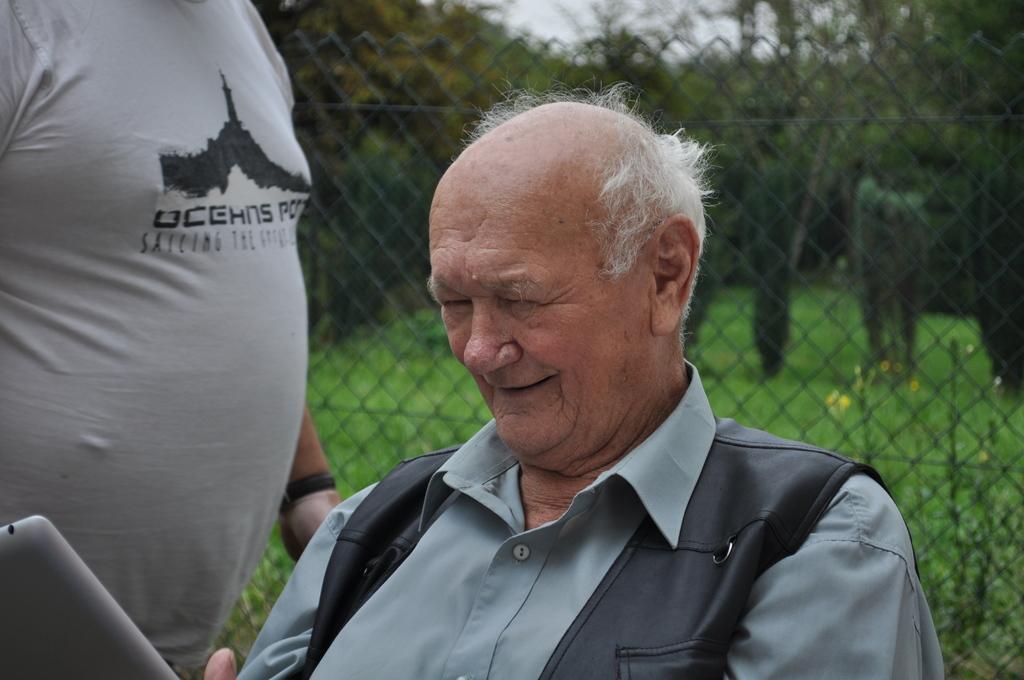In one or two sentences, can you explain what this image depicts? In this image I can see a person wearing grey and black colored dress is holding a grey colored object. I can see another person wearing grey and black colored dress is stunning. In the background I can see the metal fence, few trees and the sky. 